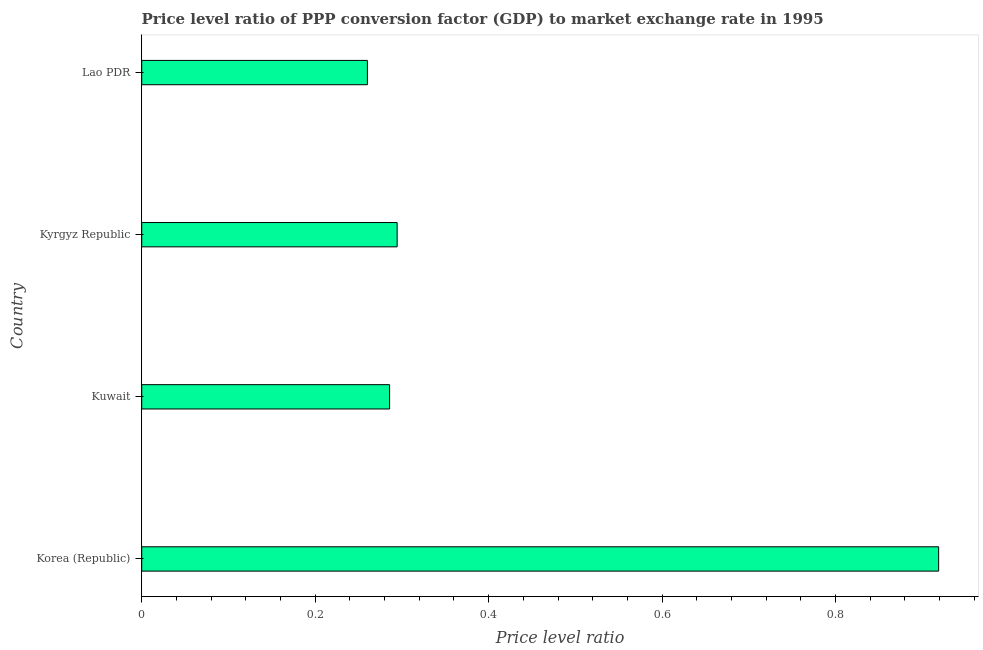Does the graph contain grids?
Keep it short and to the point. No. What is the title of the graph?
Provide a succinct answer. Price level ratio of PPP conversion factor (GDP) to market exchange rate in 1995. What is the label or title of the X-axis?
Offer a very short reply. Price level ratio. What is the price level ratio in Kuwait?
Ensure brevity in your answer.  0.29. Across all countries, what is the maximum price level ratio?
Keep it short and to the point. 0.92. Across all countries, what is the minimum price level ratio?
Offer a terse response. 0.26. In which country was the price level ratio maximum?
Provide a short and direct response. Korea (Republic). In which country was the price level ratio minimum?
Offer a terse response. Lao PDR. What is the sum of the price level ratio?
Provide a short and direct response. 1.76. What is the difference between the price level ratio in Korea (Republic) and Lao PDR?
Offer a terse response. 0.66. What is the average price level ratio per country?
Ensure brevity in your answer.  0.44. What is the median price level ratio?
Provide a short and direct response. 0.29. What is the ratio of the price level ratio in Korea (Republic) to that in Kyrgyz Republic?
Your answer should be compact. 3.12. What is the difference between the highest and the second highest price level ratio?
Ensure brevity in your answer.  0.62. What is the difference between the highest and the lowest price level ratio?
Provide a short and direct response. 0.66. How many bars are there?
Offer a very short reply. 4. Are all the bars in the graph horizontal?
Your response must be concise. Yes. What is the Price level ratio of Korea (Republic)?
Ensure brevity in your answer.  0.92. What is the Price level ratio in Kuwait?
Give a very brief answer. 0.29. What is the Price level ratio of Kyrgyz Republic?
Provide a succinct answer. 0.29. What is the Price level ratio of Lao PDR?
Make the answer very short. 0.26. What is the difference between the Price level ratio in Korea (Republic) and Kuwait?
Provide a short and direct response. 0.63. What is the difference between the Price level ratio in Korea (Republic) and Kyrgyz Republic?
Provide a short and direct response. 0.62. What is the difference between the Price level ratio in Korea (Republic) and Lao PDR?
Offer a terse response. 0.66. What is the difference between the Price level ratio in Kuwait and Kyrgyz Republic?
Offer a terse response. -0.01. What is the difference between the Price level ratio in Kuwait and Lao PDR?
Your answer should be compact. 0.03. What is the difference between the Price level ratio in Kyrgyz Republic and Lao PDR?
Offer a very short reply. 0.03. What is the ratio of the Price level ratio in Korea (Republic) to that in Kuwait?
Provide a succinct answer. 3.21. What is the ratio of the Price level ratio in Korea (Republic) to that in Kyrgyz Republic?
Offer a very short reply. 3.12. What is the ratio of the Price level ratio in Korea (Republic) to that in Lao PDR?
Your answer should be very brief. 3.53. What is the ratio of the Price level ratio in Kuwait to that in Lao PDR?
Keep it short and to the point. 1.1. What is the ratio of the Price level ratio in Kyrgyz Republic to that in Lao PDR?
Provide a succinct answer. 1.13. 